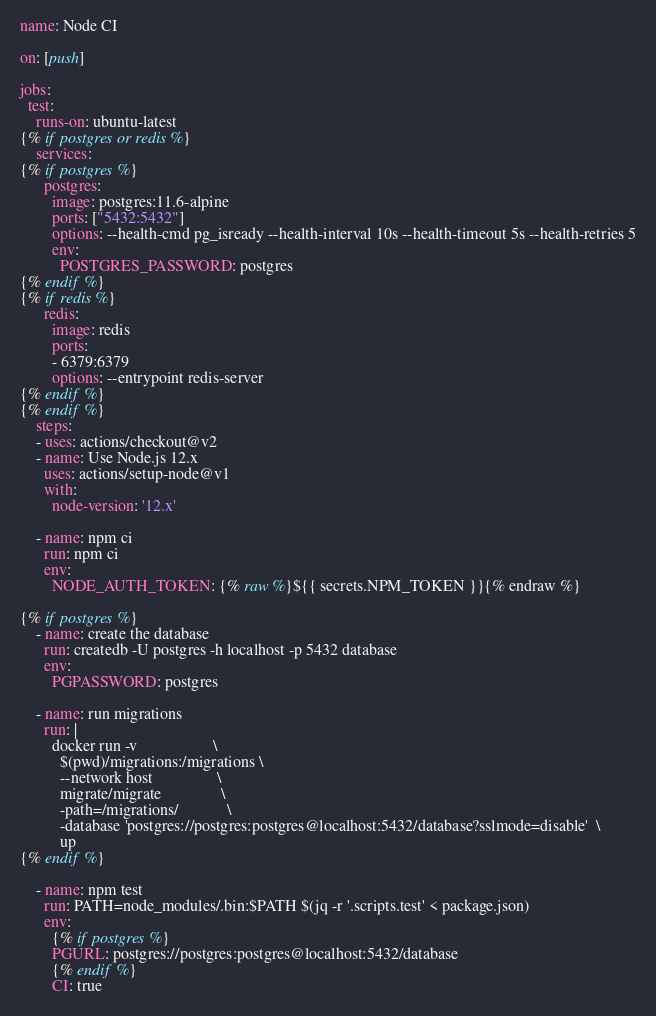<code> <loc_0><loc_0><loc_500><loc_500><_YAML_>name: Node CI

on: [push]

jobs:
  test:
    runs-on: ubuntu-latest
{% if postgres or redis %}
    services:
{% if postgres %}
      postgres:
        image: postgres:11.6-alpine
        ports: ["5432:5432"]
        options: --health-cmd pg_isready --health-interval 10s --health-timeout 5s --health-retries 5
        env:
          POSTGRES_PASSWORD: postgres
{% endif %}
{% if redis %}
      redis:
        image: redis
        ports:
        - 6379:6379
        options: --entrypoint redis-server
{% endif %}
{% endif %}
    steps:
    - uses: actions/checkout@v2
    - name: Use Node.js 12.x
      uses: actions/setup-node@v1
      with:
        node-version: '12.x'

    - name: npm ci
      run: npm ci
      env:
        NODE_AUTH_TOKEN: {% raw %}${{ secrets.NPM_TOKEN }}{% endraw %}

{% if postgres %}
    - name: create the database
      run: createdb -U postgres -h localhost -p 5432 database
      env:
        PGPASSWORD: postgres

    - name: run migrations
      run: |
        docker run -v                   \
          $(pwd)/migrations:/migrations \
          --network host                \
          migrate/migrate               \
          -path=/migrations/            \
          -database 'postgres://postgres:postgres@localhost:5432/database?sslmode=disable'  \
          up
{% endif %}

    - name: npm test
      run: PATH=node_modules/.bin:$PATH $(jq -r '.scripts.test' < package.json)
      env:
        {% if postgres %}
        PGURL: postgres://postgres:postgres@localhost:5432/database
        {% endif %}
        CI: true
</code> 